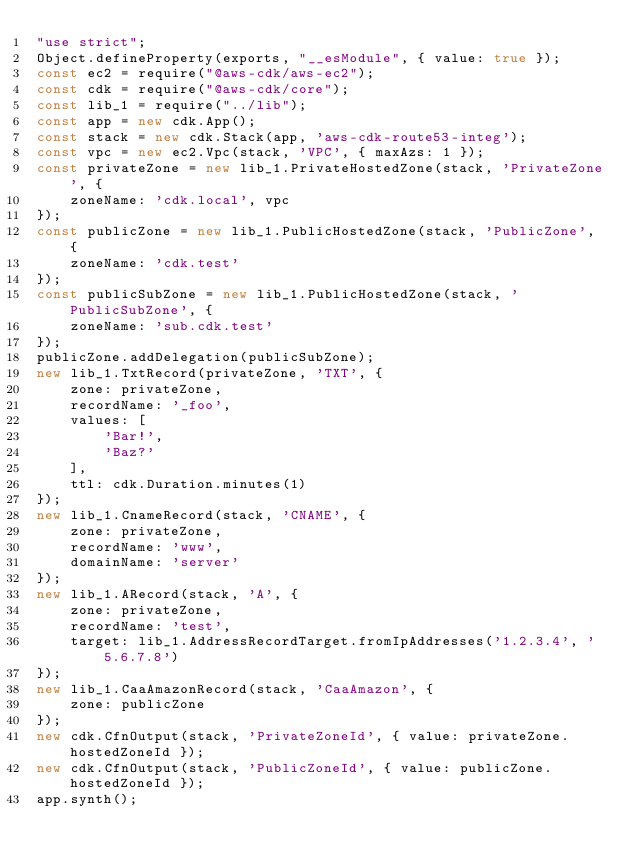Convert code to text. <code><loc_0><loc_0><loc_500><loc_500><_JavaScript_>"use strict";
Object.defineProperty(exports, "__esModule", { value: true });
const ec2 = require("@aws-cdk/aws-ec2");
const cdk = require("@aws-cdk/core");
const lib_1 = require("../lib");
const app = new cdk.App();
const stack = new cdk.Stack(app, 'aws-cdk-route53-integ');
const vpc = new ec2.Vpc(stack, 'VPC', { maxAzs: 1 });
const privateZone = new lib_1.PrivateHostedZone(stack, 'PrivateZone', {
    zoneName: 'cdk.local', vpc
});
const publicZone = new lib_1.PublicHostedZone(stack, 'PublicZone', {
    zoneName: 'cdk.test'
});
const publicSubZone = new lib_1.PublicHostedZone(stack, 'PublicSubZone', {
    zoneName: 'sub.cdk.test'
});
publicZone.addDelegation(publicSubZone);
new lib_1.TxtRecord(privateZone, 'TXT', {
    zone: privateZone,
    recordName: '_foo',
    values: [
        'Bar!',
        'Baz?'
    ],
    ttl: cdk.Duration.minutes(1)
});
new lib_1.CnameRecord(stack, 'CNAME', {
    zone: privateZone,
    recordName: 'www',
    domainName: 'server'
});
new lib_1.ARecord(stack, 'A', {
    zone: privateZone,
    recordName: 'test',
    target: lib_1.AddressRecordTarget.fromIpAddresses('1.2.3.4', '5.6.7.8')
});
new lib_1.CaaAmazonRecord(stack, 'CaaAmazon', {
    zone: publicZone
});
new cdk.CfnOutput(stack, 'PrivateZoneId', { value: privateZone.hostedZoneId });
new cdk.CfnOutput(stack, 'PublicZoneId', { value: publicZone.hostedZoneId });
app.synth();</code> 